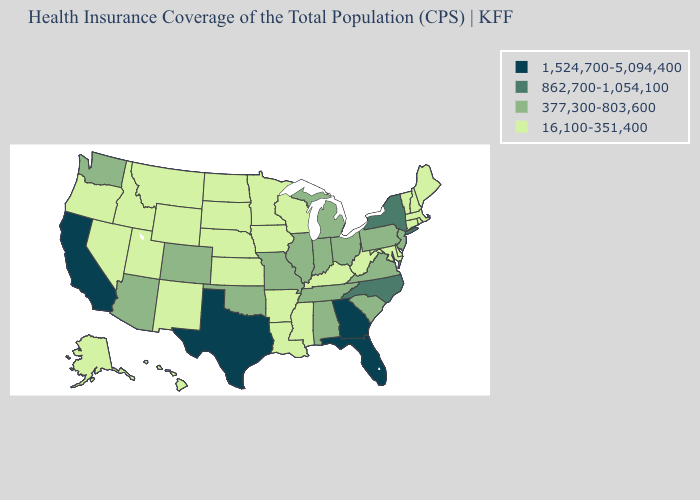Does Ohio have the highest value in the USA?
Quick response, please. No. Name the states that have a value in the range 377,300-803,600?
Quick response, please. Alabama, Arizona, Colorado, Illinois, Indiana, Michigan, Missouri, New Jersey, Ohio, Oklahoma, Pennsylvania, South Carolina, Tennessee, Virginia, Washington. Does the first symbol in the legend represent the smallest category?
Answer briefly. No. Does New Hampshire have a lower value than Tennessee?
Short answer required. Yes. Does Missouri have the highest value in the MidWest?
Answer briefly. Yes. Does Georgia have the highest value in the USA?
Write a very short answer. Yes. Name the states that have a value in the range 16,100-351,400?
Short answer required. Alaska, Arkansas, Connecticut, Delaware, Hawaii, Idaho, Iowa, Kansas, Kentucky, Louisiana, Maine, Maryland, Massachusetts, Minnesota, Mississippi, Montana, Nebraska, Nevada, New Hampshire, New Mexico, North Dakota, Oregon, Rhode Island, South Dakota, Utah, Vermont, West Virginia, Wisconsin, Wyoming. What is the value of Arkansas?
Quick response, please. 16,100-351,400. Does the first symbol in the legend represent the smallest category?
Give a very brief answer. No. Does South Dakota have the highest value in the USA?
Write a very short answer. No. What is the value of North Dakota?
Quick response, please. 16,100-351,400. What is the value of Oregon?
Answer briefly. 16,100-351,400. Does the map have missing data?
Concise answer only. No. What is the value of Missouri?
Concise answer only. 377,300-803,600. Name the states that have a value in the range 1,524,700-5,094,400?
Concise answer only. California, Florida, Georgia, Texas. 